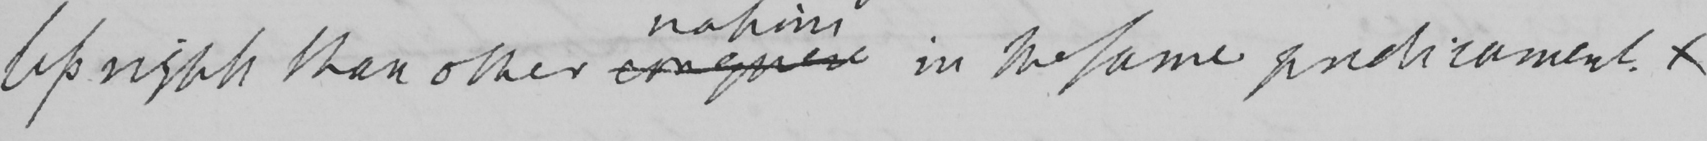Please provide the text content of this handwritten line. less rights than other conquer in the same predicament . 